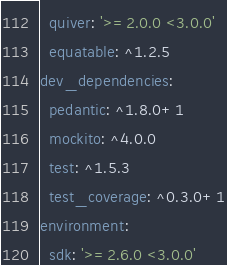<code> <loc_0><loc_0><loc_500><loc_500><_YAML_>  quiver: '>=2.0.0 <3.0.0'
  equatable: ^1.2.5
dev_dependencies:
  pedantic: ^1.8.0+1
  mockito: ^4.0.0
  test: ^1.5.3
  test_coverage: ^0.3.0+1
environment:
  sdk: '>=2.6.0 <3.0.0'
</code> 